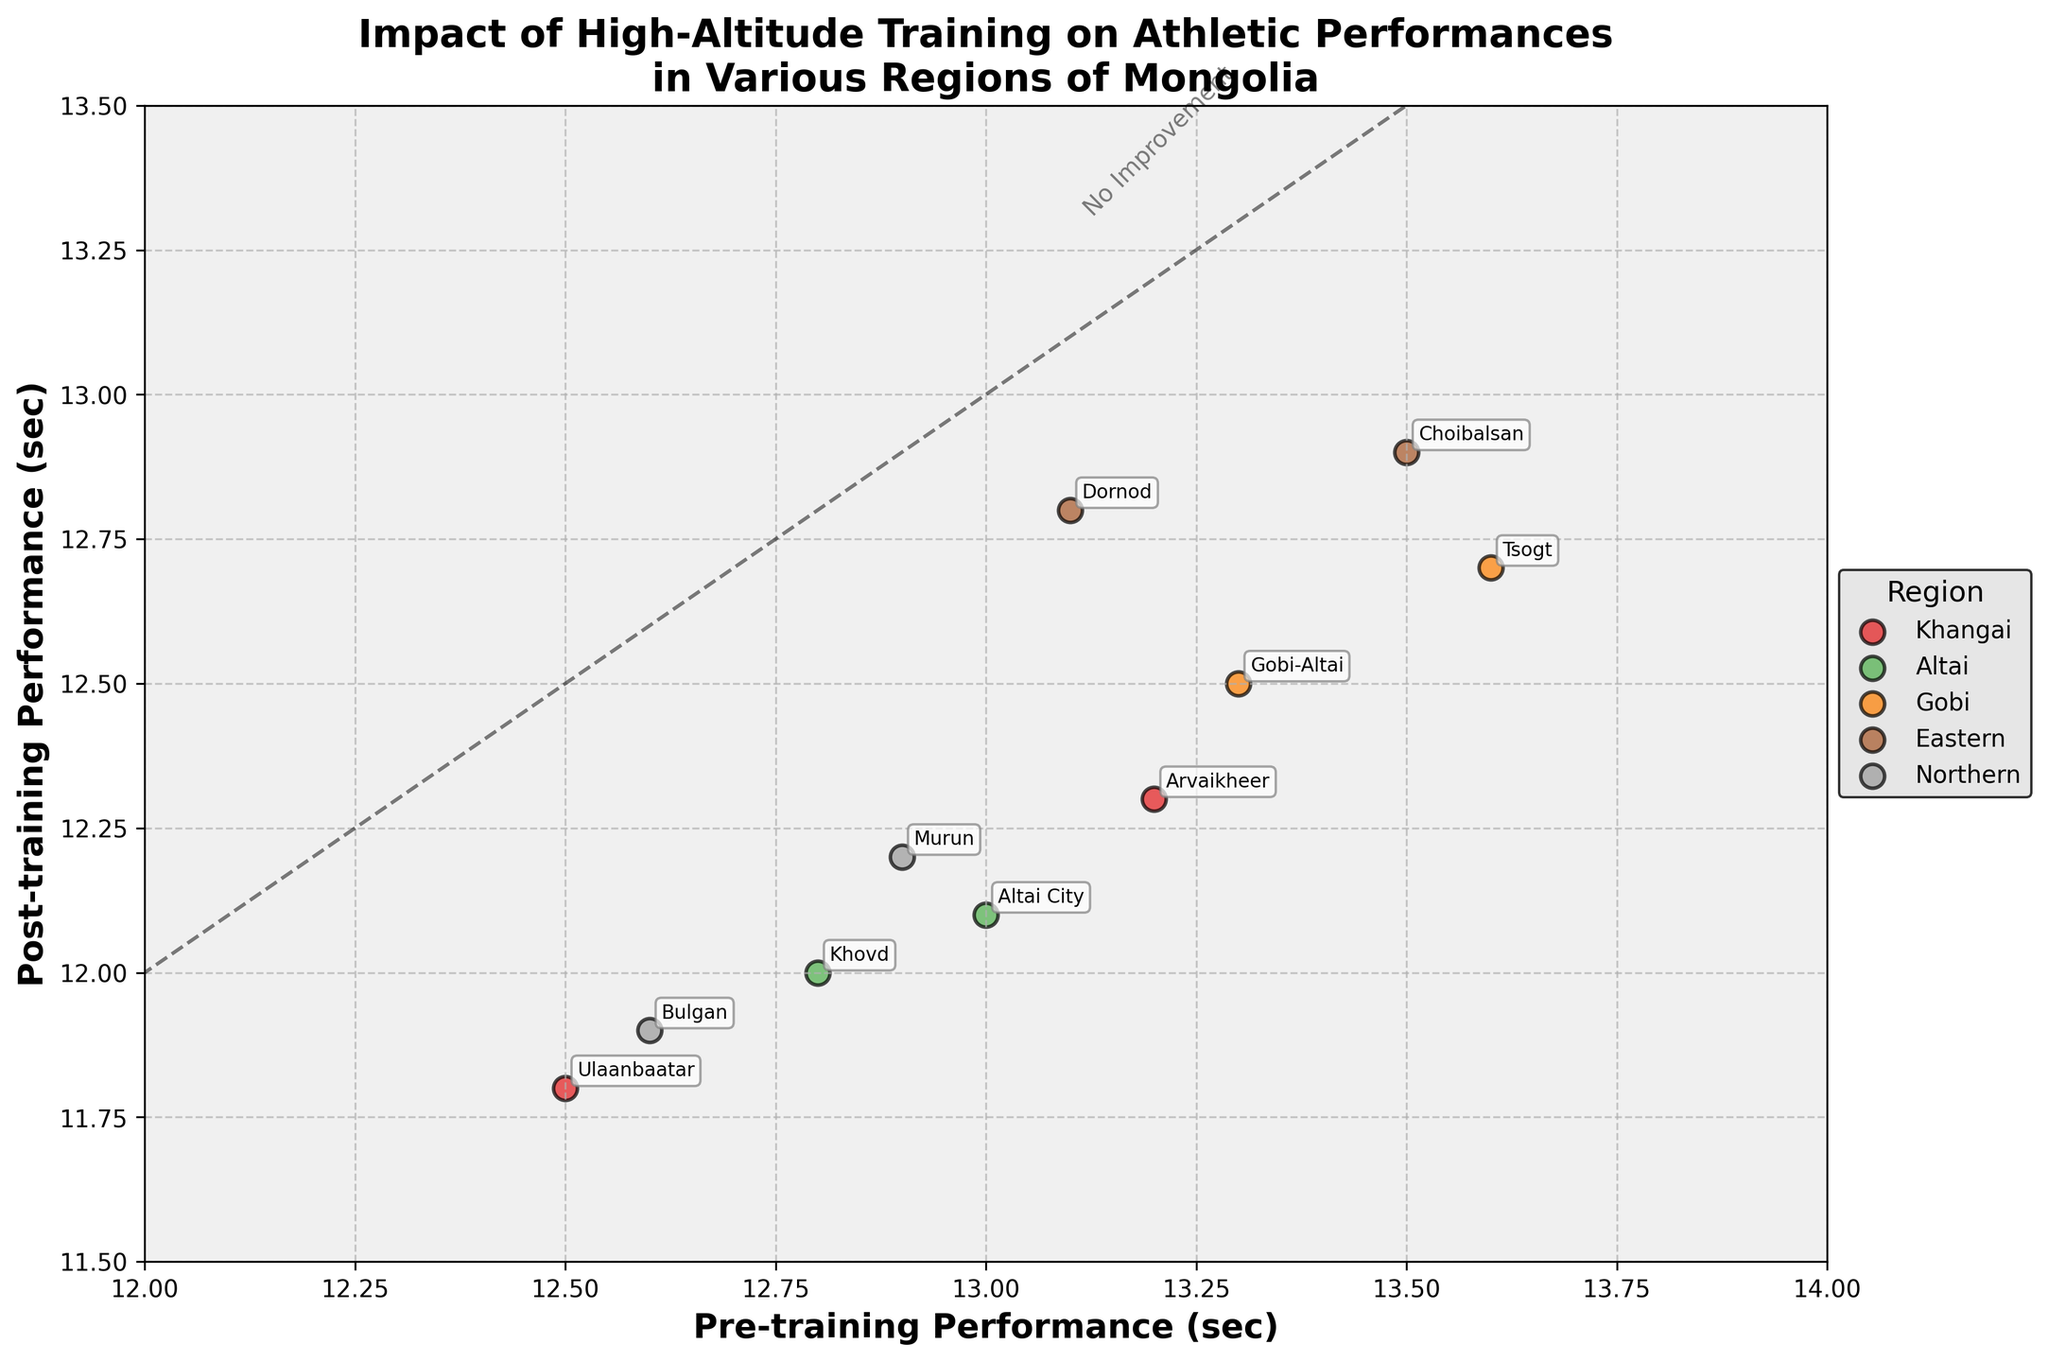What is the title of the plot? The title is typically displayed at the top of the figure. It reads: "Impact of High-Altitude Training on Athletic Performances in Various Regions of Mongolia."
Answer: Impact of High-Altitude Training on Athletic Performances in Various Regions of Mongolia What are the x and y-axis labels? The x and y-axis labels are shown next to their respective axes. The x-axis is labeled "Pre-training Performance (sec)," and the y-axis is labeled "Post-training Performance (sec)."
Answer: Pre-training Performance (sec) and Post-training Performance (sec) How many regions are represented in the plot? The number of regions is indicated by the different colors and the legend title "Region." There are five regions: Khangai, Altai, Gobi, Eastern, and Northern.
Answer: Five Which region showed the highest improvement after training? To find the highest improvement, compare the distance between the pre-training and post-training performances for all regions. The largest gap is with the Khangai region (Arvaikheer) with pre-training at 13.2 seconds and post-training at 12.3 seconds.
Answer: Khangai What is the location with the best pre-training performance? The best pre-training performance is indicated by the lowest value on the x-axis. Ulaanbaatar in the Khangai region has a pre-training performance of 12.5 seconds.
Answer: Ulaanbaatar Which location has the closest pre-training and post-training performances? Look for the points closest to the dashed "No Improvement" line, which indicates similar pre- and post-training performances. The location is Dornod in the Eastern region with pre-training at 13.1 seconds and post-training at 12.8 seconds.
Answer: Dornod Comparing regions Khangai and Gobi, which one shows a better average post-training performance? First, find the average post-training performances for both regions. 
  Khangai: (11.8 + 12.3) / 2 = 12.05. 
  Gobi: (12.5 + 12.7) / 2 = 12.6. 
Thus, the Khangai region has a better average post-training performance.
Answer: Khangai Which location in the Altai region had the best post-training performance? Check the post-training performances in the Altai region and find the lowest value. Altai City has a post-training performance of 12.1 seconds.
Answer: Altai City Do any data points lie exactly on the "No Improvement" line? The "No Improvement" line is a dashed line representing the same pre- and post-training performance (y = x). None of the data points lie exactly on this line.
Answer: No What is the average pre-training performance for the Northern region? Calculate the average pre-training performance for the two locations in the Northern region: (12.6 + 12.9) / 2 = 12.75.
Answer: 12.75 